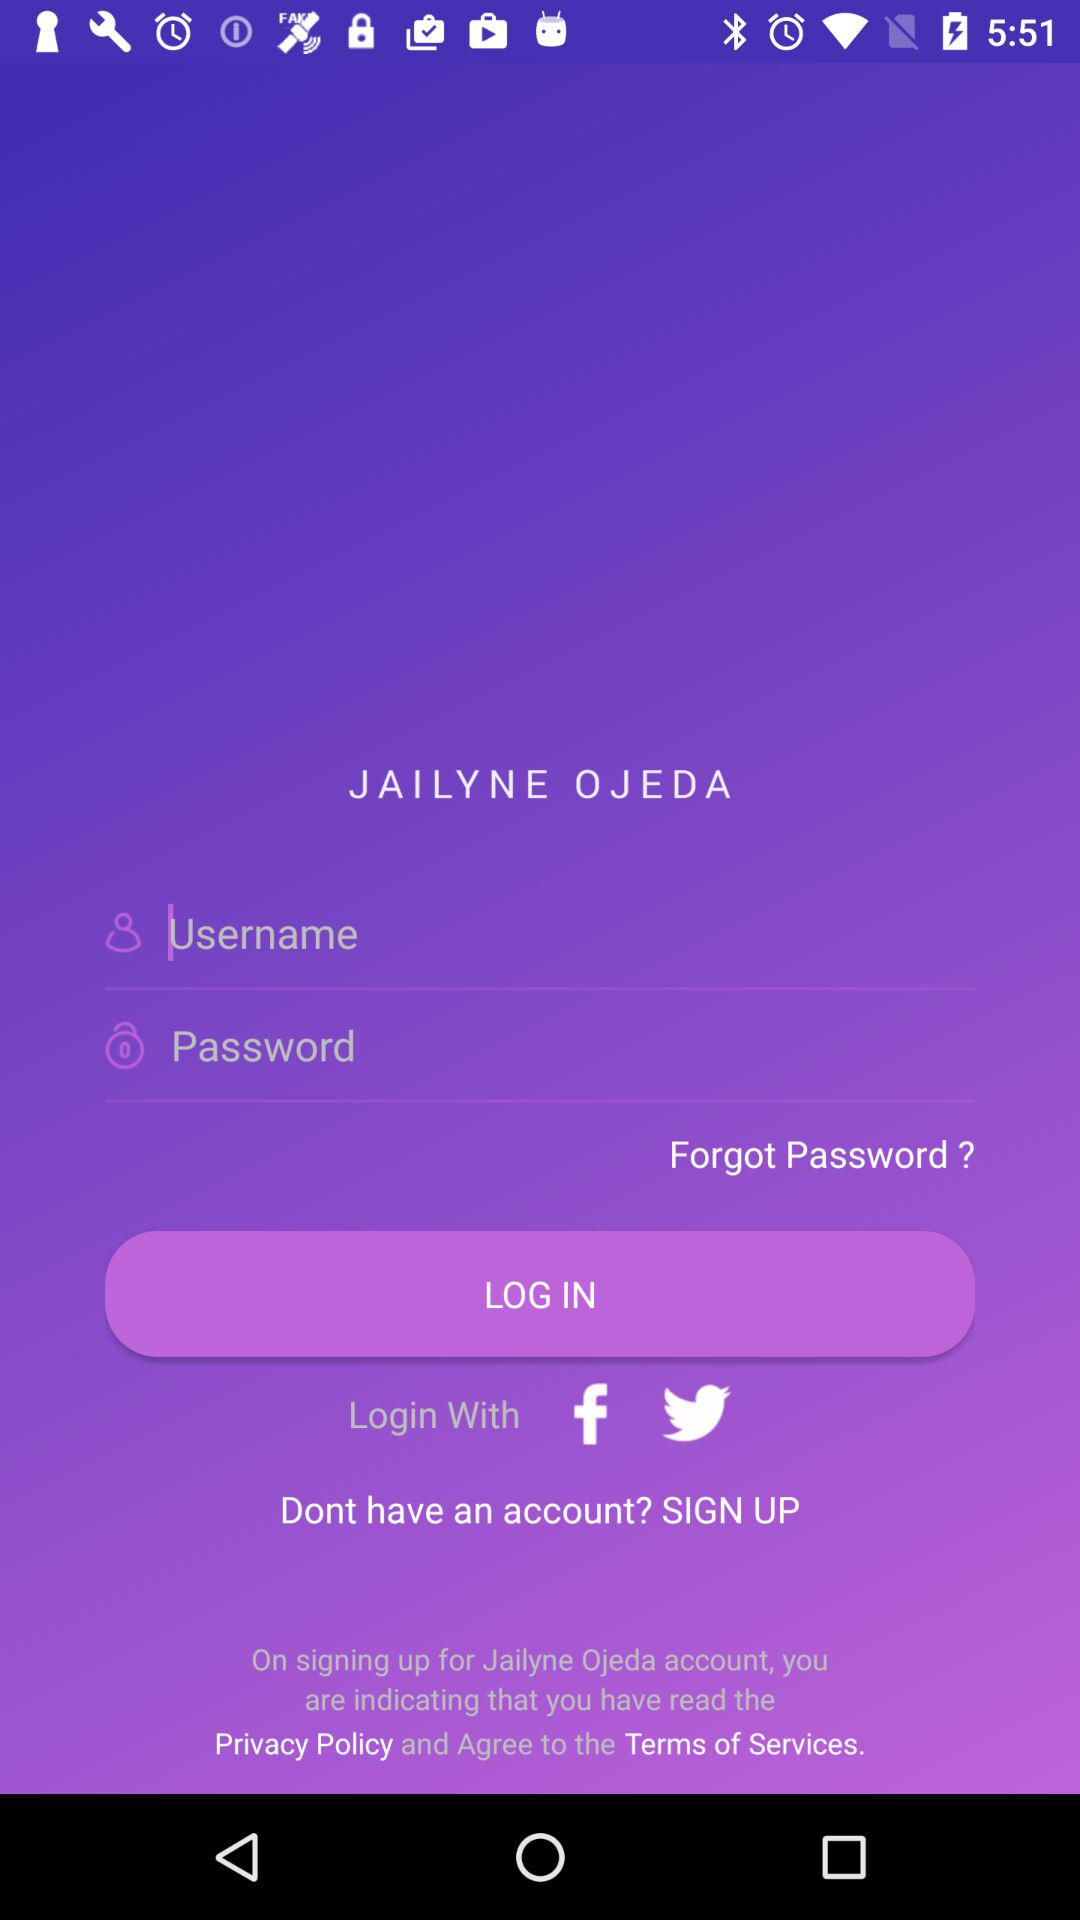What are the different options through which we can log in? You can log in through "Facebook" and "Twitter". 